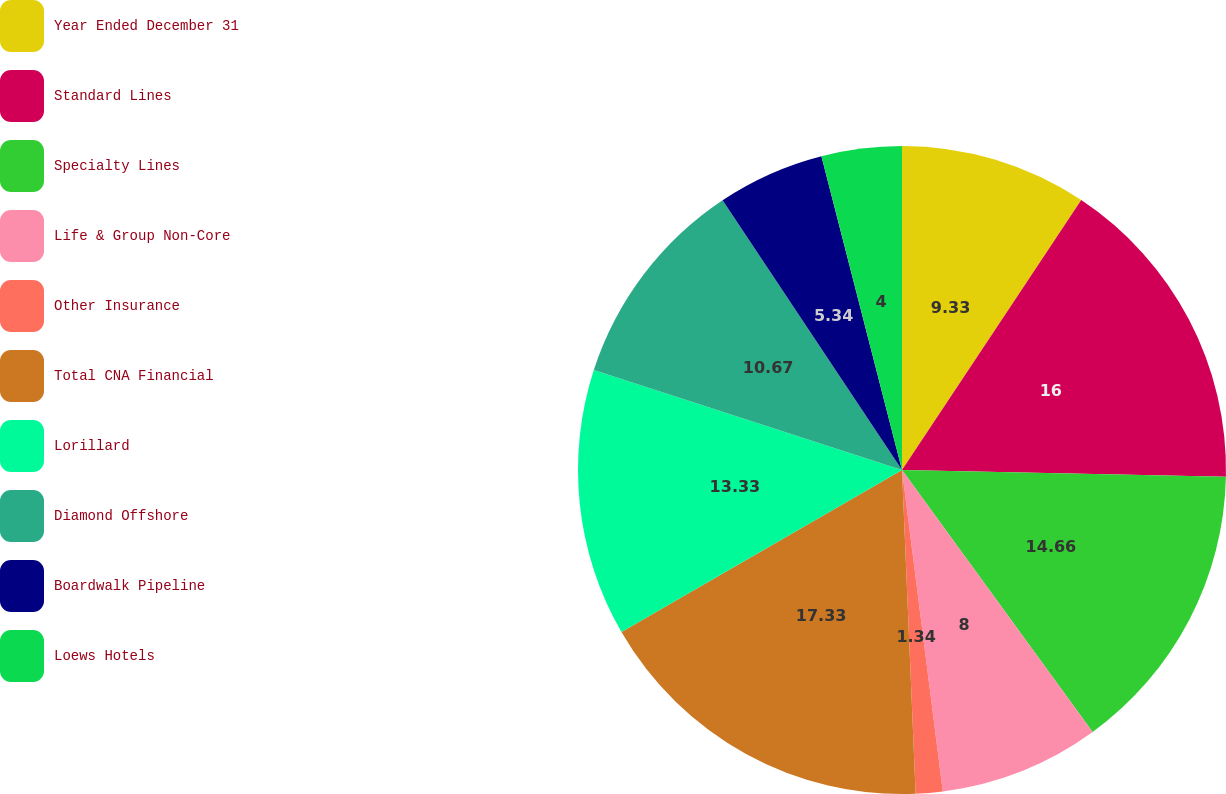<chart> <loc_0><loc_0><loc_500><loc_500><pie_chart><fcel>Year Ended December 31<fcel>Standard Lines<fcel>Specialty Lines<fcel>Life & Group Non-Core<fcel>Other Insurance<fcel>Total CNA Financial<fcel>Lorillard<fcel>Diamond Offshore<fcel>Boardwalk Pipeline<fcel>Loews Hotels<nl><fcel>9.33%<fcel>16.0%<fcel>14.66%<fcel>8.0%<fcel>1.34%<fcel>17.33%<fcel>13.33%<fcel>10.67%<fcel>5.34%<fcel>4.0%<nl></chart> 